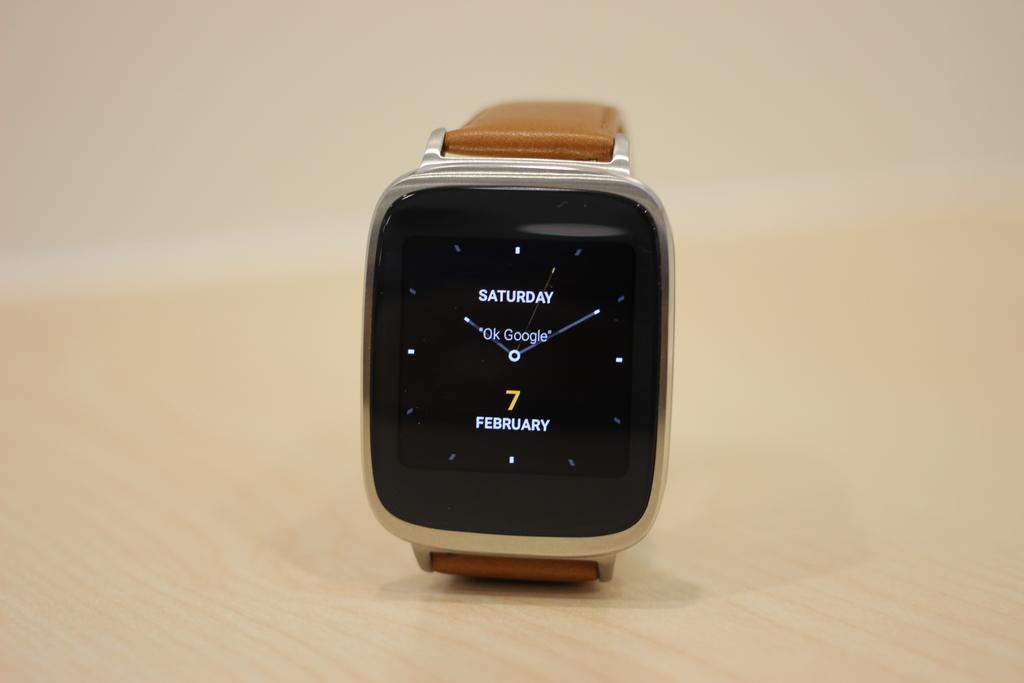What day of the week is displayed?
Make the answer very short. Saturday. What type of watch is this?
Keep it short and to the point. Google. 